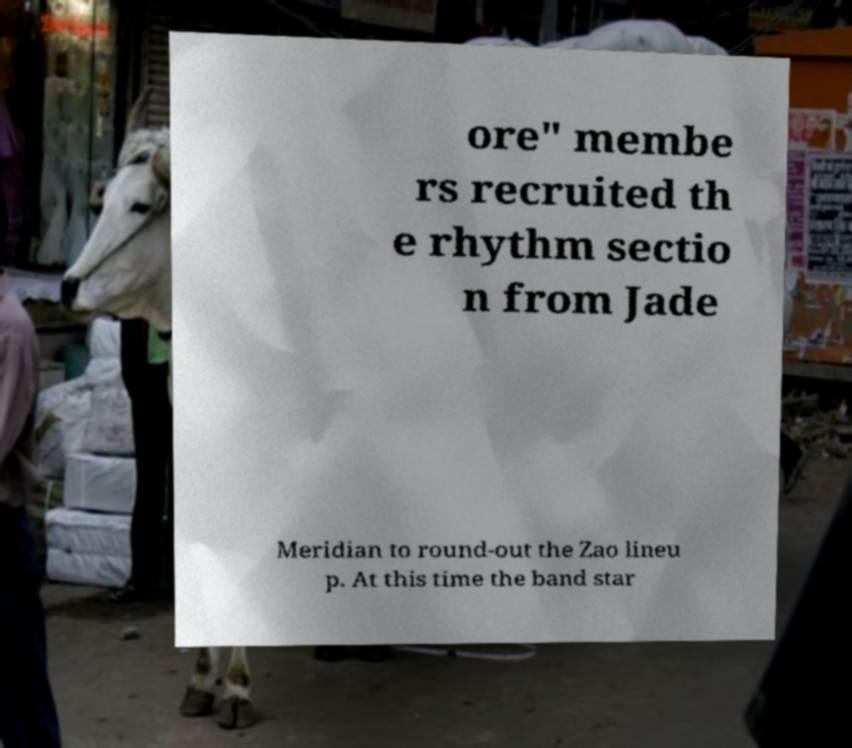Could you extract and type out the text from this image? ore" membe rs recruited th e rhythm sectio n from Jade Meridian to round-out the Zao lineu p. At this time the band star 